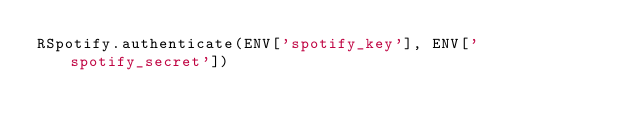<code> <loc_0><loc_0><loc_500><loc_500><_Ruby_>RSpotify.authenticate(ENV['spotify_key'], ENV['spotify_secret'])</code> 